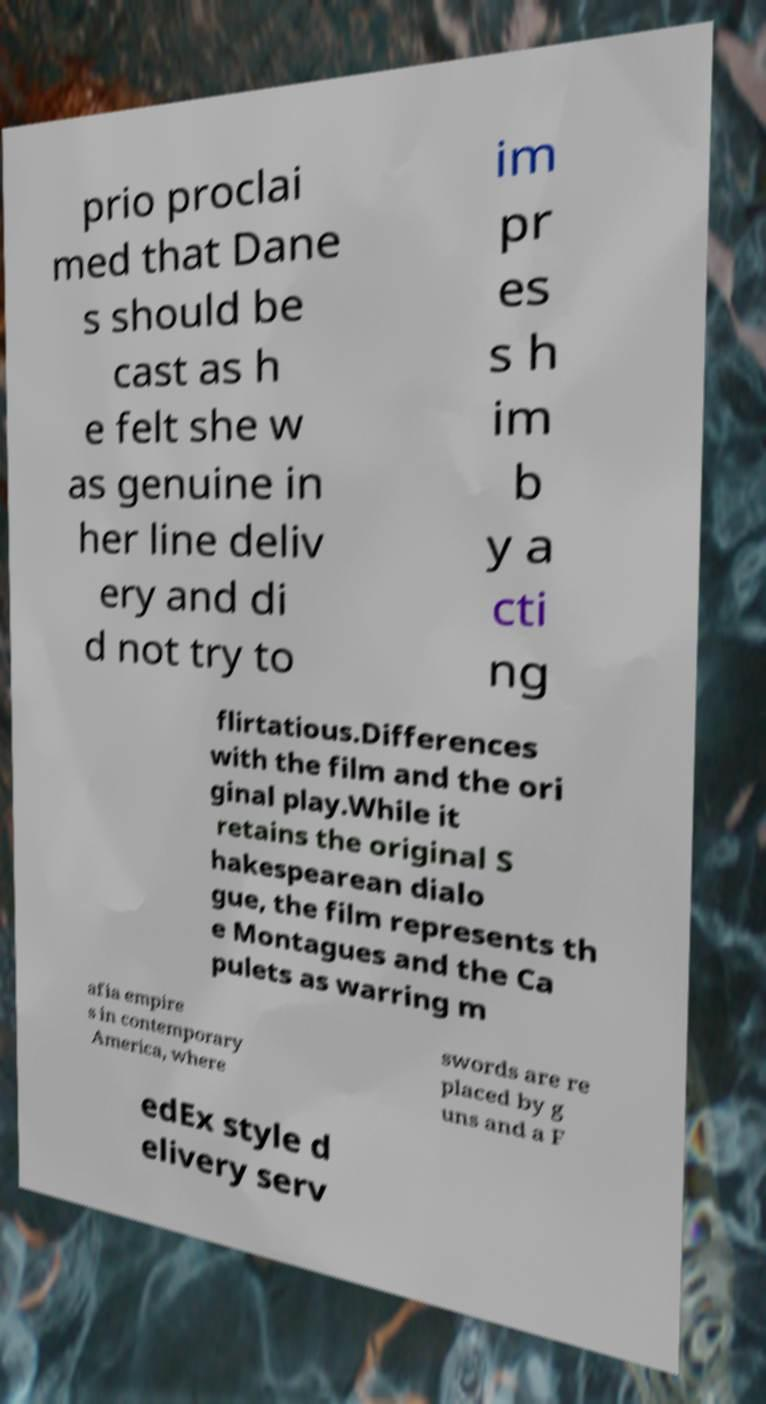Please identify and transcribe the text found in this image. prio proclai med that Dane s should be cast as h e felt she w as genuine in her line deliv ery and di d not try to im pr es s h im b y a cti ng flirtatious.Differences with the film and the ori ginal play.While it retains the original S hakespearean dialo gue, the film represents th e Montagues and the Ca pulets as warring m afia empire s in contemporary America, where swords are re placed by g uns and a F edEx style d elivery serv 